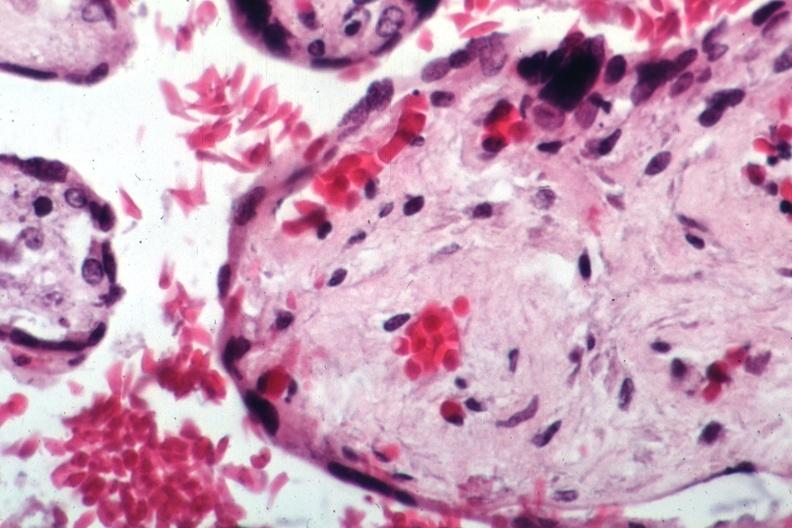s history present?
Answer the question using a single word or phrase. No 